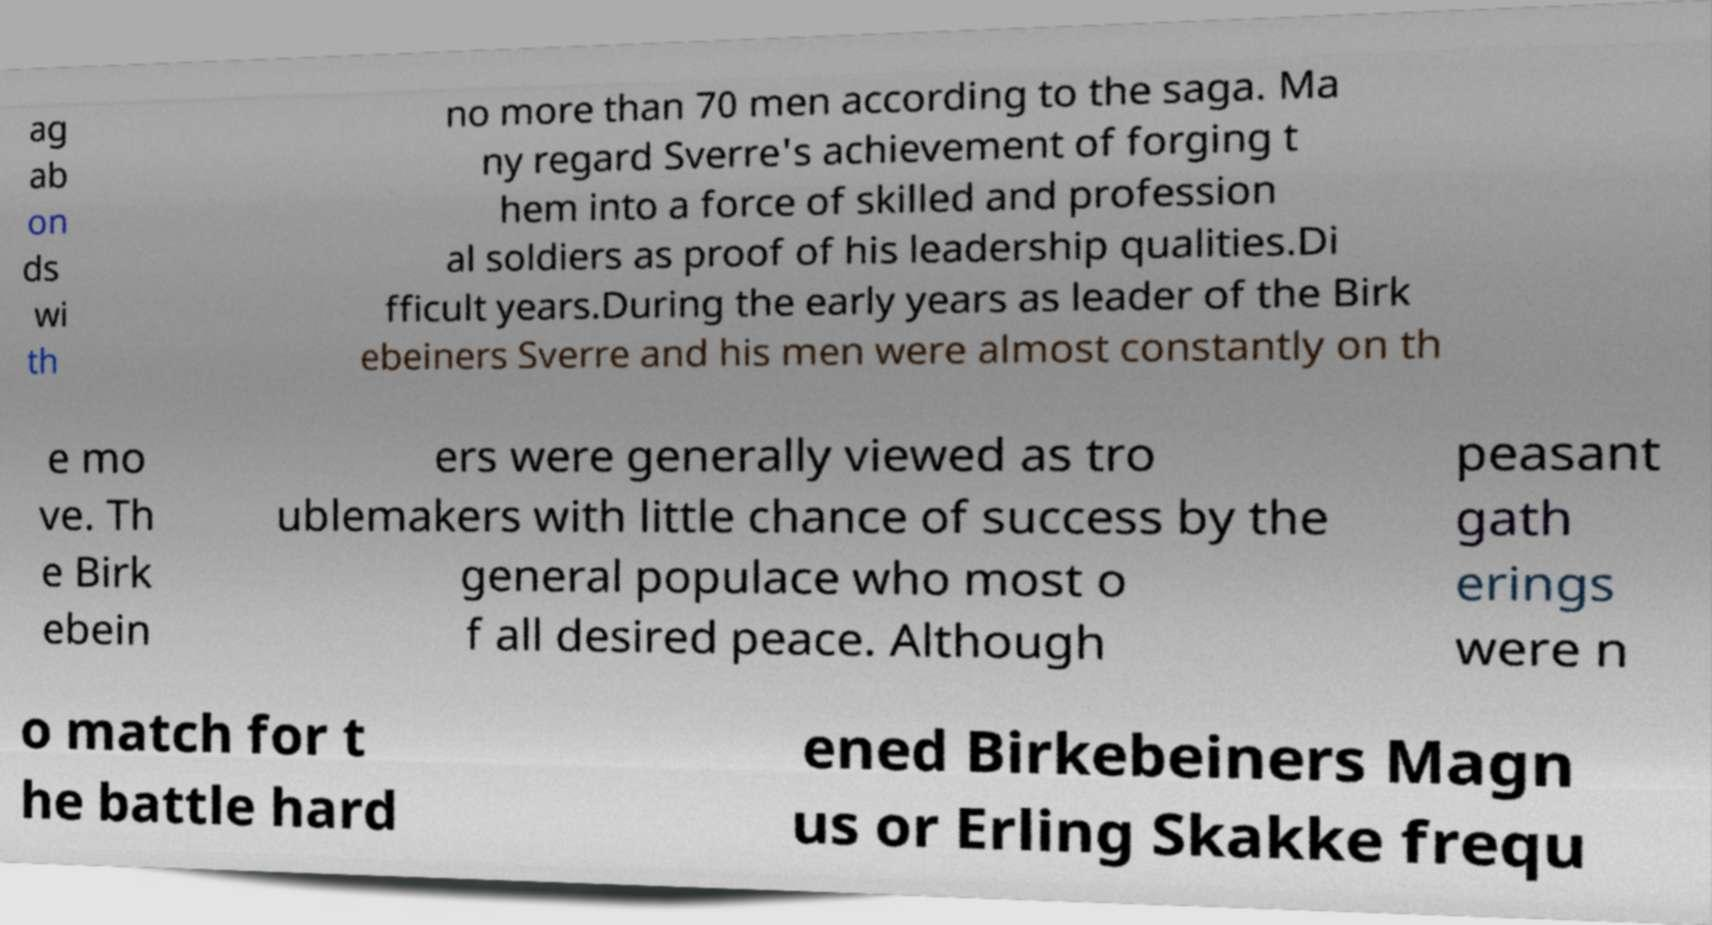Please identify and transcribe the text found in this image. ag ab on ds wi th no more than 70 men according to the saga. Ma ny regard Sverre's achievement of forging t hem into a force of skilled and profession al soldiers as proof of his leadership qualities.Di fficult years.During the early years as leader of the Birk ebeiners Sverre and his men were almost constantly on th e mo ve. Th e Birk ebein ers were generally viewed as tro ublemakers with little chance of success by the general populace who most o f all desired peace. Although peasant gath erings were n o match for t he battle hard ened Birkebeiners Magn us or Erling Skakke frequ 